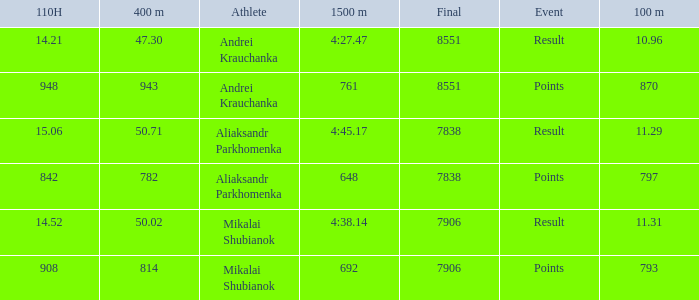What was the 400m that had a 110H greater than 14.21, a final of more than 7838, and having result in events? 1.0. 